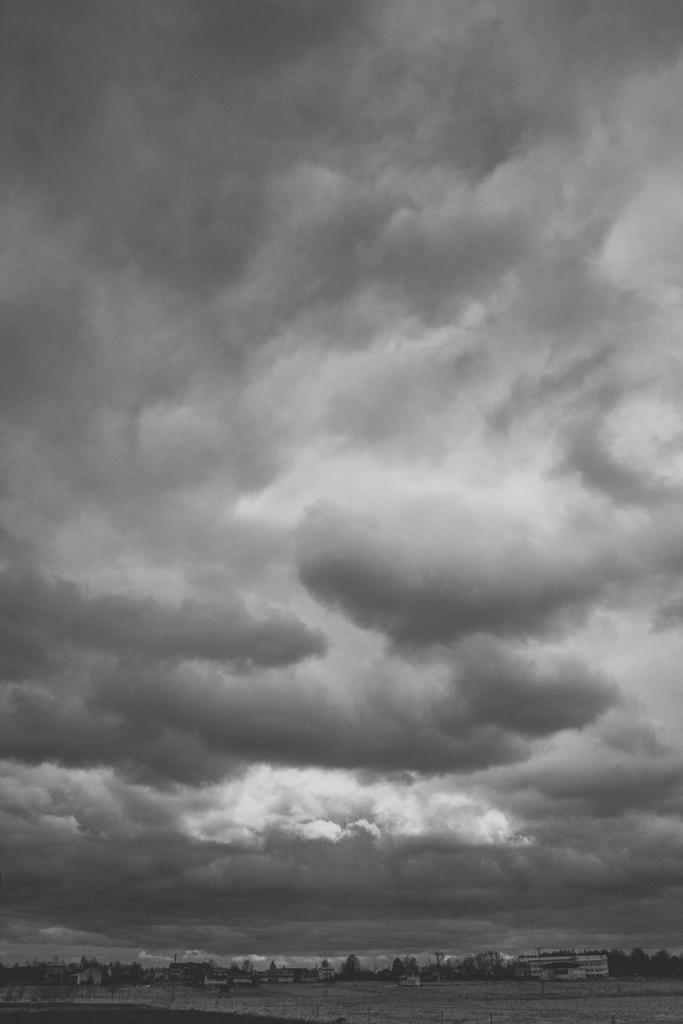How would you summarize this image in a sentence or two? This image is taken outdoors. This image is a black and white image. At the top of the image there is the sky with clouds. At the bottom of the image there is a ground. In the background there are many trees and plants and there are a few buildings. 